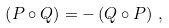Convert formula to latex. <formula><loc_0><loc_0><loc_500><loc_500>\left ( P \circ Q \right ) = - \left ( Q \circ P \right ) \, ,</formula> 